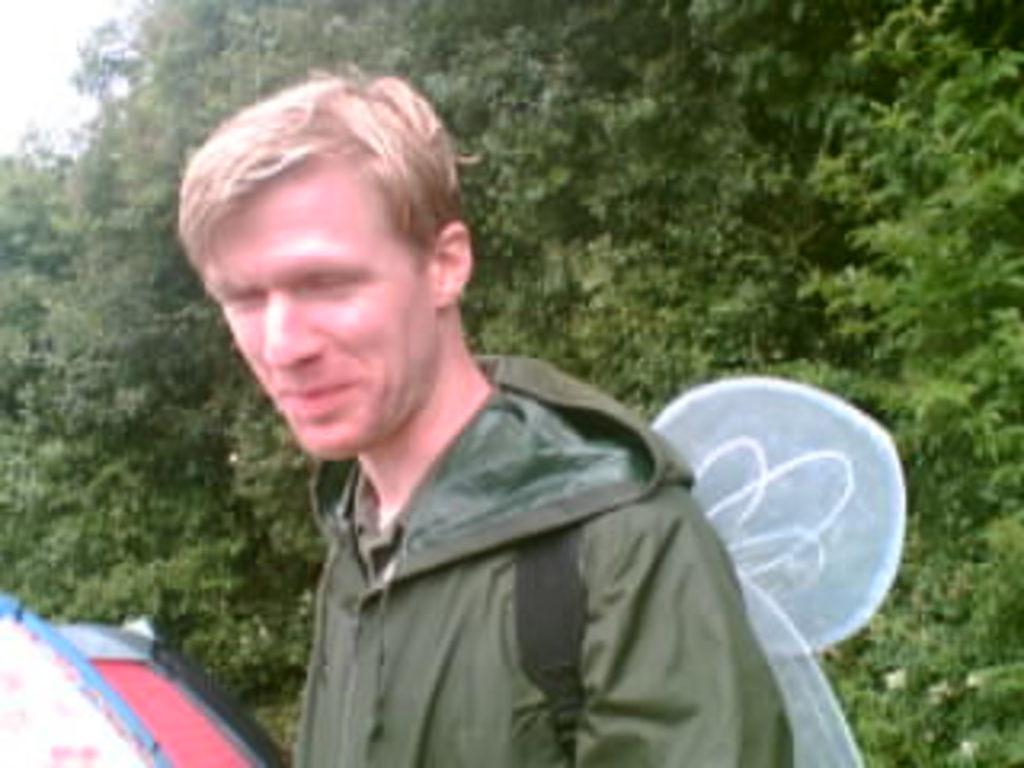How would you summarize this image in a sentence or two? In this picture there is a man wearing a green jacket and he is carrying something. In the background there are trees and sky. 